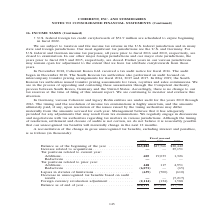According to Coherent's financial document, What was the Balance as of end of year in 2019? According to the financial document, $58,111 (in thousands). The relevant text states: ". (2,114) (134) 1,588 Balance as of end of year . $58,111 $65,882 $47,566..." Also, What was the  Balance as of the beginning of the year  in 2018? According to the financial document, $47,566 (in thousands). The relevant text states: "Balance as of the beginning of the year . $65,882 $47,566 $20,442 Increase related to acquisitions . — — 25,151 Tax positions related to current year: Additio..." Also, In which years was the Balance as of end of year calculated? The document contains multiple relevant values: 2019, 2018, 2017. From the document: "Fiscal year-end 2019 2018 2017 Fiscal year-end 2019 2018 2017 Fiscal year-end 2019 2018 2017..." Additionally, In which year was the Balance as of the beginning of the year the largest? According to the financial document, 2019. The relevant text states: "Fiscal year-end 2019 2018 2017..." Also, can you calculate: What was the change in Balance as of the beginning of the year in 2019 from 2018? Based on the calculation: 65,882-47,566, the result is 18316 (in thousands). This is based on the information: "Balance as of the beginning of the year . $65,882 $47,566 $20,442 Increase related to acquisitions . — — 25,151 Tax positions related to current year alance as of the beginning of the year . $65,882 $..." The key data points involved are: 47,566, 65,882. Also, can you calculate: What was the percentage change in Balance as of the beginning of the year in 2019 from 2018? To answer this question, I need to perform calculations using the financial data. The calculation is: (65,882-47,566)/47,566, which equals 38.51 (percentage). This is based on the information: "Balance as of the beginning of the year . $65,882 $47,566 $20,442 Increase related to acquisitions . — — 25,151 Tax positions related to current year alance as of the beginning of the year . $65,882 $..." The key data points involved are: 47,566, 65,882. 